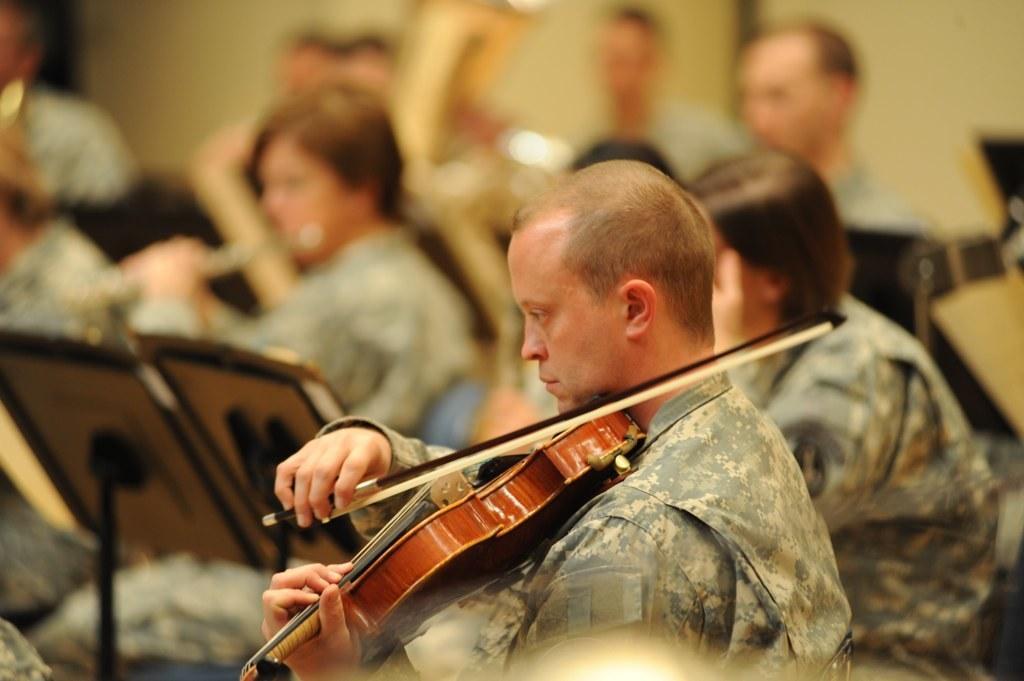Can you describe this image briefly? in the picture there are many people sitting and playing different musical instruments a man was playing a guitar. 